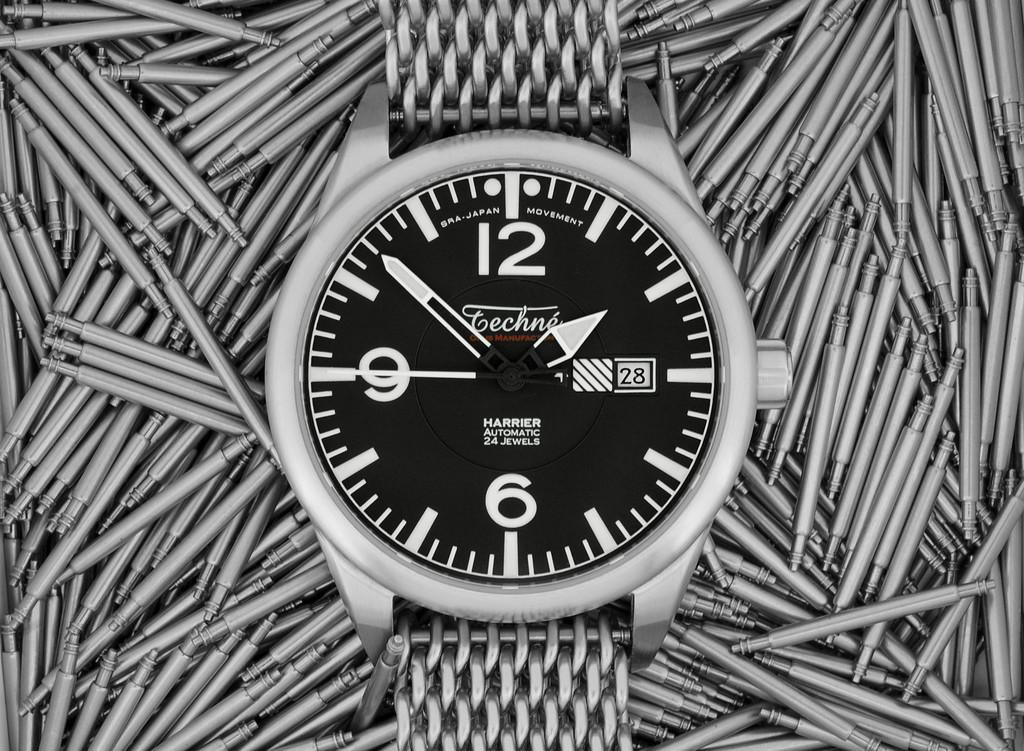<image>
Share a concise interpretation of the image provided. The stainless steel watch currently shows the time of 1:52 and the 28th day of the month. 